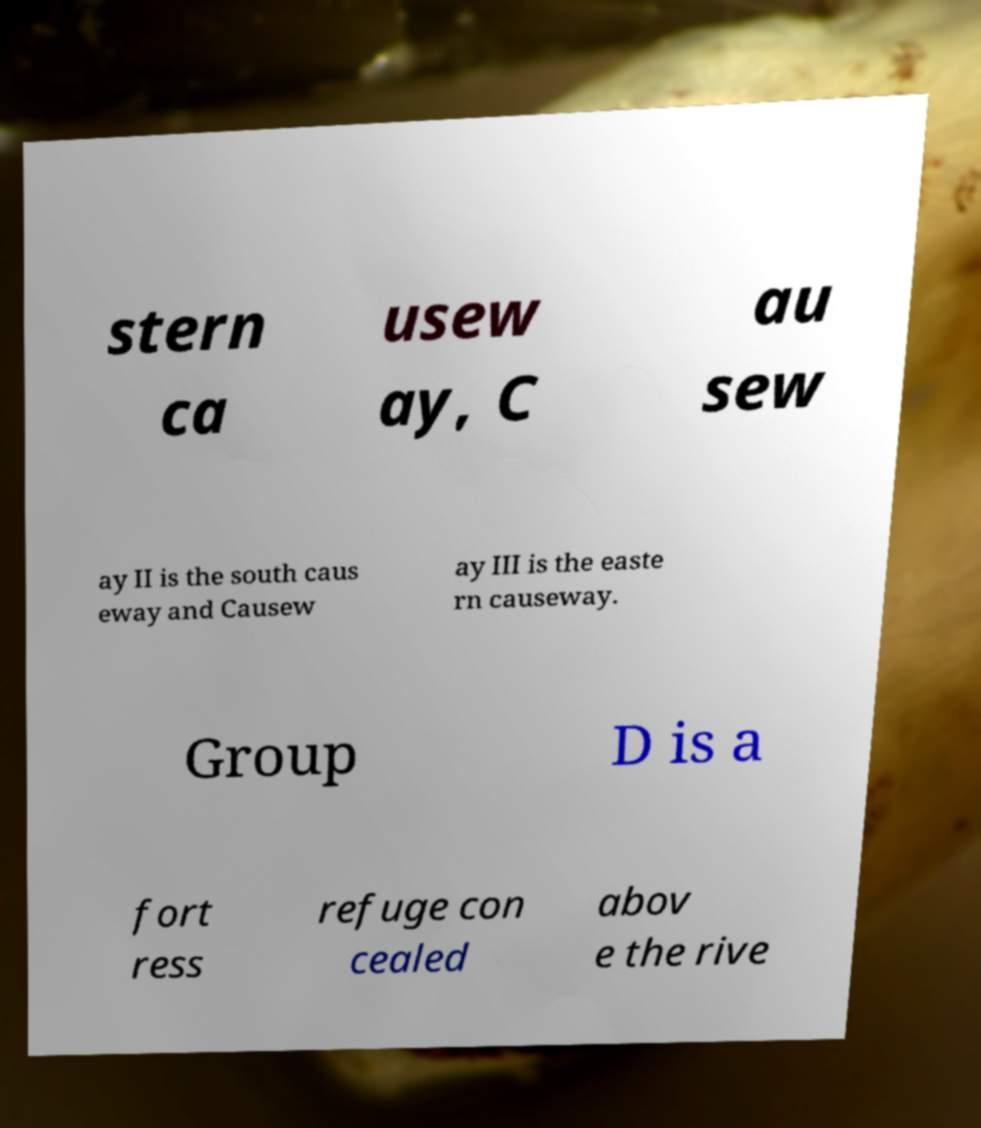Please read and relay the text visible in this image. What does it say? stern ca usew ay, C au sew ay II is the south caus eway and Causew ay III is the easte rn causeway. Group D is a fort ress refuge con cealed abov e the rive 